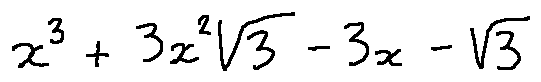<formula> <loc_0><loc_0><loc_500><loc_500>x ^ { 3 } + 3 x ^ { 2 } \sqrt { 3 } - 3 x - \sqrt { 3 }</formula> 